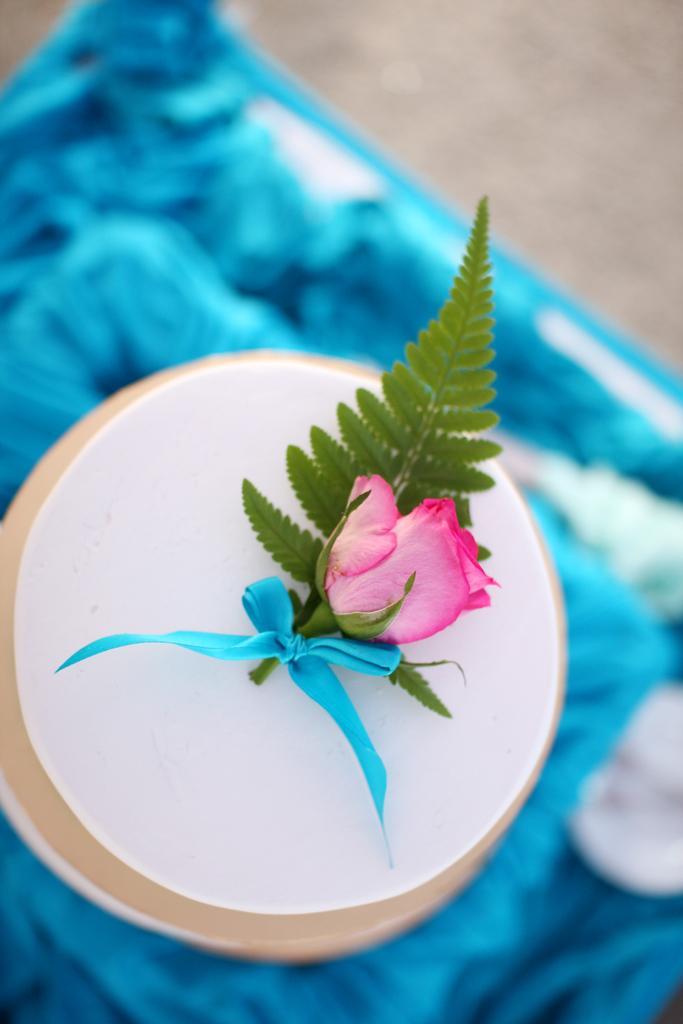Could you give a brief overview of what you see in this image? In this image there is a table. There is a plate. There is a rose with leaf. 